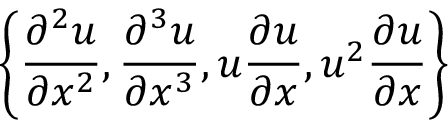Convert formula to latex. <formula><loc_0><loc_0><loc_500><loc_500>\left \{ \frac { \partial ^ { 2 } u } { \partial x ^ { 2 } } , \frac { \partial ^ { 3 } u } { \partial x ^ { 3 } } , u \frac { \partial u } { \partial x } , u ^ { 2 } \frac { \partial u } { \partial x } \right \}</formula> 